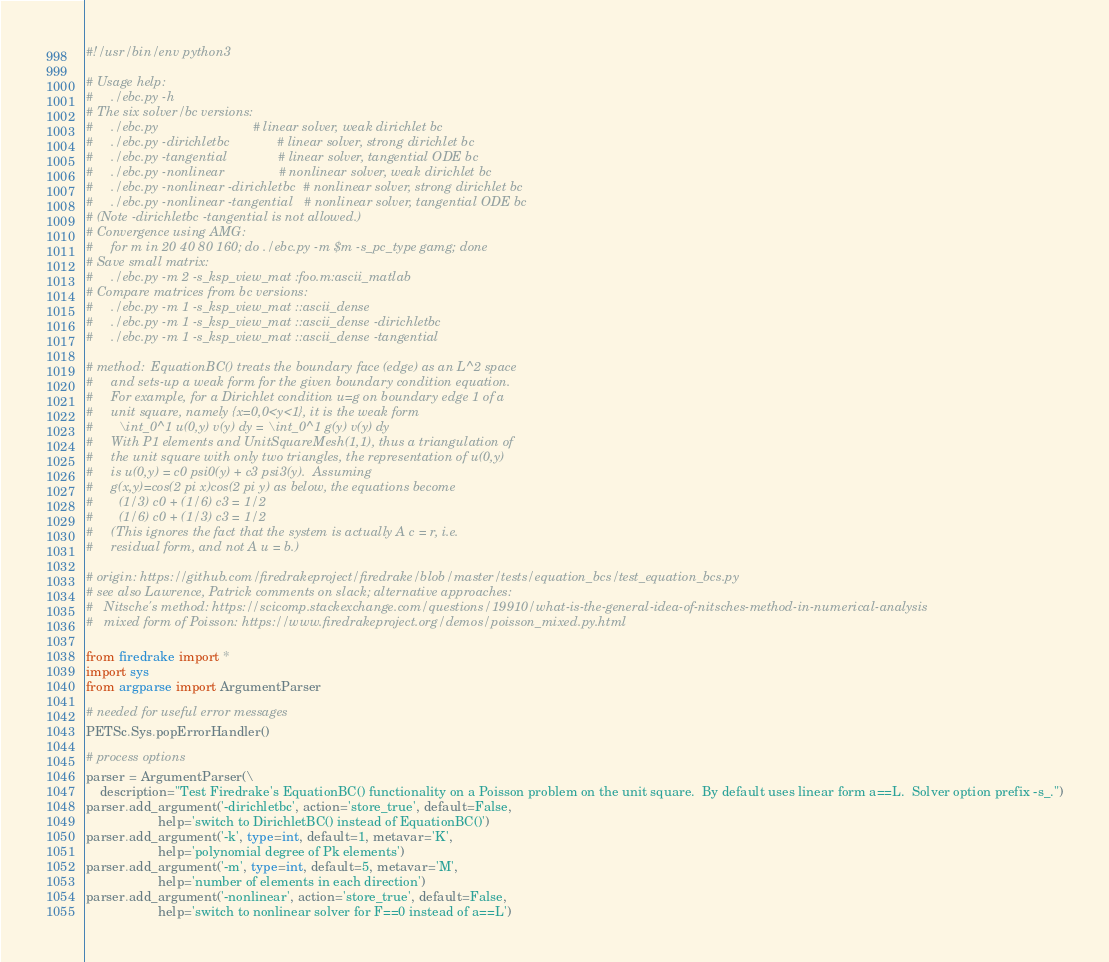<code> <loc_0><loc_0><loc_500><loc_500><_Python_>#!/usr/bin/env python3

# Usage help:
#     ./ebc.py -h
# The six solver/bc versions:
#     ./ebc.py                          # linear solver, weak dirichlet bc
#     ./ebc.py -dirichletbc             # linear solver, strong dirichlet bc
#     ./ebc.py -tangential              # linear solver, tangential ODE bc
#     ./ebc.py -nonlinear               # nonlinear solver, weak dirichlet bc
#     ./ebc.py -nonlinear -dirichletbc  # nonlinear solver, strong dirichlet bc
#     ./ebc.py -nonlinear -tangential   # nonlinear solver, tangential ODE bc
# (Note -dirichletbc -tangential is not allowed.)
# Convergence using AMG:
#     for m in 20 40 80 160; do ./ebc.py -m $m -s_pc_type gamg; done
# Save small matrix:
#     ./ebc.py -m 2 -s_ksp_view_mat :foo.m:ascii_matlab
# Compare matrices from bc versions:
#     ./ebc.py -m 1 -s_ksp_view_mat ::ascii_dense
#     ./ebc.py -m 1 -s_ksp_view_mat ::ascii_dense -dirichletbc
#     ./ebc.py -m 1 -s_ksp_view_mat ::ascii_dense -tangential

# method:  EquationBC() treats the boundary face (edge) as an L^2 space
#     and sets-up a weak form for the given boundary condition equation.
#     For example, for a Dirichlet condition u=g on boundary edge 1 of a
#     unit square, namely {x=0,0<y<1}, it is the weak form
#       \int_0^1 u(0,y) v(y) dy = \int_0^1 g(y) v(y) dy
#     With P1 elements and UnitSquareMesh(1,1), thus a triangulation of
#     the unit square with only two triangles, the representation of u(0,y)
#     is u(0,y) = c0 psi0(y) + c3 psi3(y).  Assuming
#     g(x,y)=cos(2 pi x)cos(2 pi y) as below, the equations become
#       (1/3) c0 + (1/6) c3 = 1/2
#       (1/6) c0 + (1/3) c3 = 1/2
#     (This ignores the fact that the system is actually A c = r, i.e.
#     residual form, and not A u = b.)

# origin: https://github.com/firedrakeproject/firedrake/blob/master/tests/equation_bcs/test_equation_bcs.py
# see also Lawrence, Patrick comments on slack; alternative approaches:
#   Nitsche's method: https://scicomp.stackexchange.com/questions/19910/what-is-the-general-idea-of-nitsches-method-in-numerical-analysis
#   mixed form of Poisson: https://www.firedrakeproject.org/demos/poisson_mixed.py.html

from firedrake import *
import sys
from argparse import ArgumentParser

# needed for useful error messages
PETSc.Sys.popErrorHandler()

# process options
parser = ArgumentParser(\
    description="Test Firedrake's EquationBC() functionality on a Poisson problem on the unit square.  By default uses linear form a==L.  Solver option prefix -s_.")
parser.add_argument('-dirichletbc', action='store_true', default=False,
                    help='switch to DirichletBC() instead of EquationBC()')
parser.add_argument('-k', type=int, default=1, metavar='K',
                    help='polynomial degree of Pk elements')
parser.add_argument('-m', type=int, default=5, metavar='M',
                    help='number of elements in each direction')
parser.add_argument('-nonlinear', action='store_true', default=False,
                    help='switch to nonlinear solver for F==0 instead of a==L')</code> 